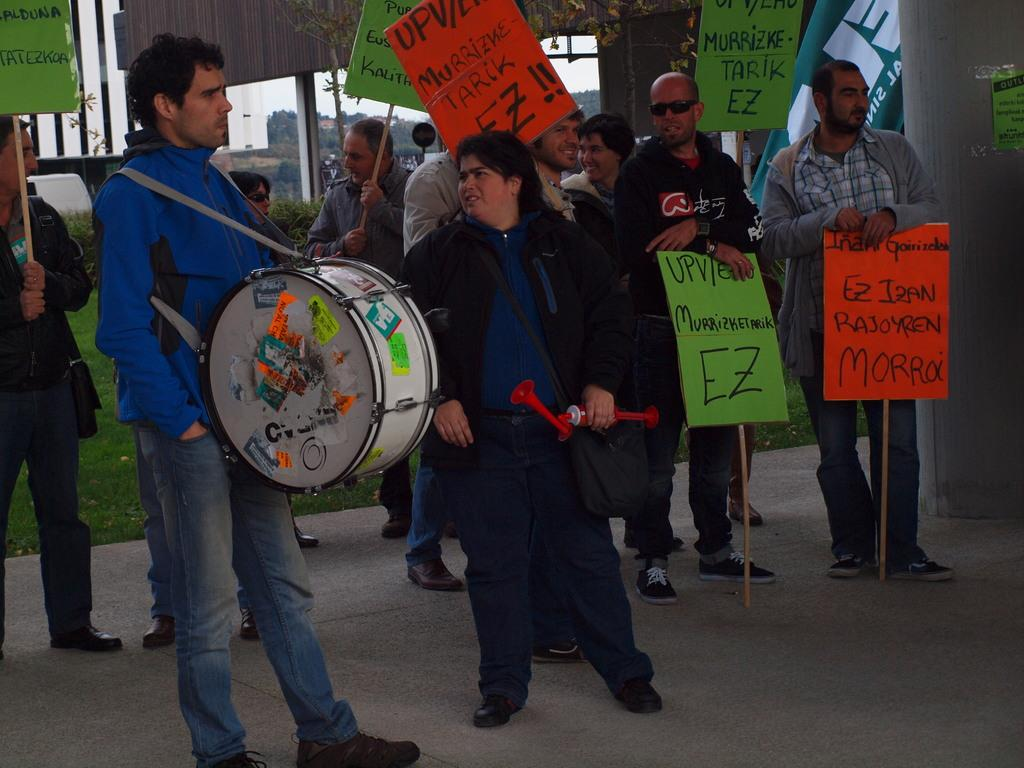What are the people in the image doing? There are persons standing on the road in the image. What musical instrument can be seen in the image? There is a drum in the image. What is one person carrying in the image? A person is carrying a bag in the image. What type of vegetation is present in the image? There is grass in the image. What architectural feature can be seen in the image? There is a pillar in the image. What objects are made of wood in the image? There are boards in the image. What type of songs can be heard coming from the jellyfish in the image? There are no jellyfish present in the image, so no songs can be heard from them. What type of writing instrument is the quill in the image? There is no quill present in the image. 